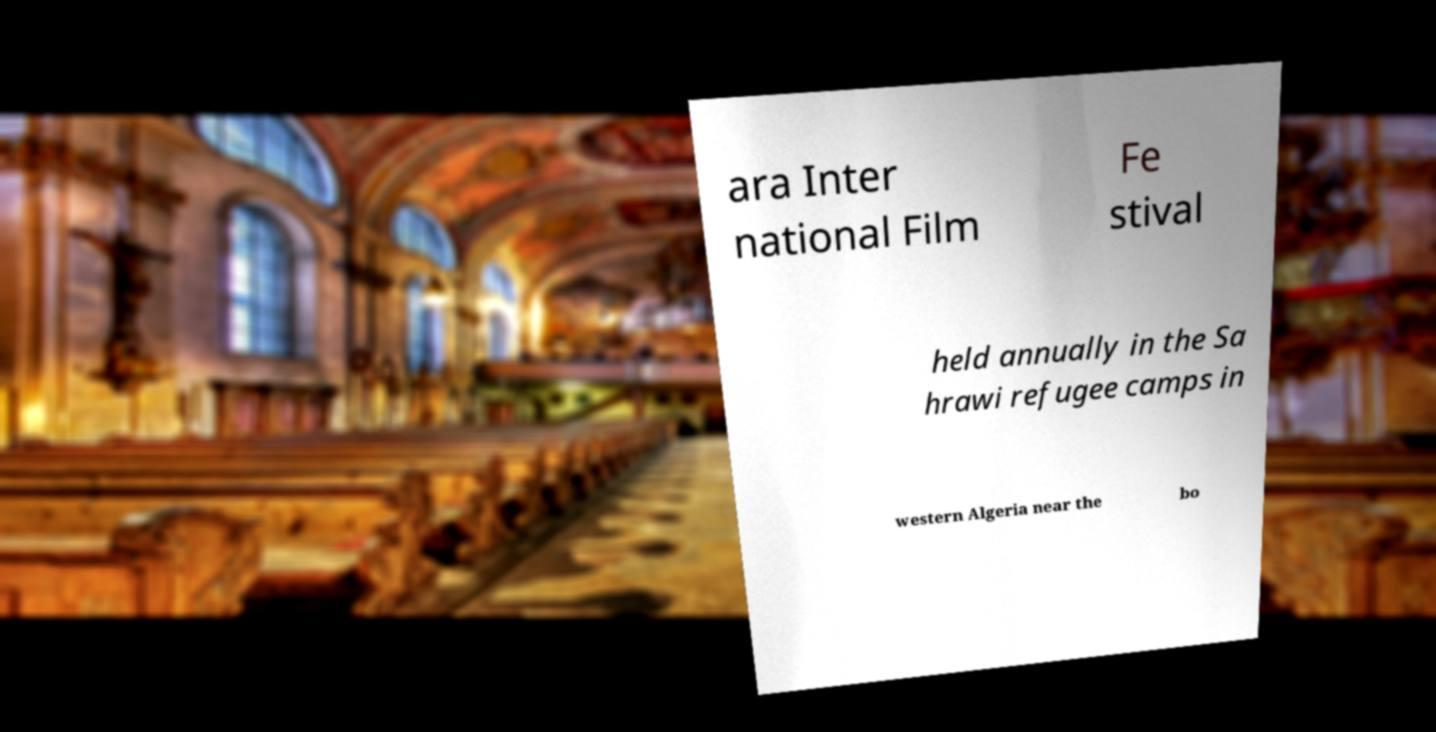I need the written content from this picture converted into text. Can you do that? ara Inter national Film Fe stival held annually in the Sa hrawi refugee camps in western Algeria near the bo 